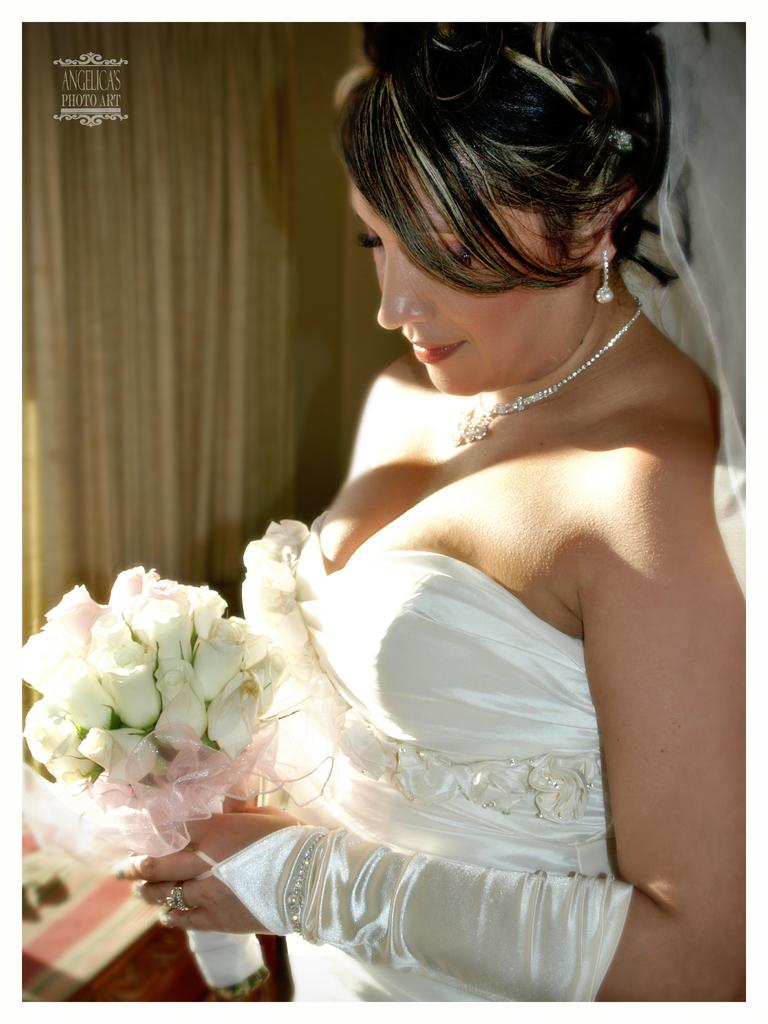Who is present in the image? There is a woman in the image. Where is the woman positioned in the image? The woman is standing on the right side of the image. What is the woman holding in her hands? The woman is holding a flower bouquet in her hands. What can be seen in the background of the image? There is a curtain in the background of the image. What type of surface is visible in the image? The image shows a floor. What type of cake is being served on the floor in the image? There is no cake present in the image; it only shows a woman holding a flower bouquet and a curtain in the background. 